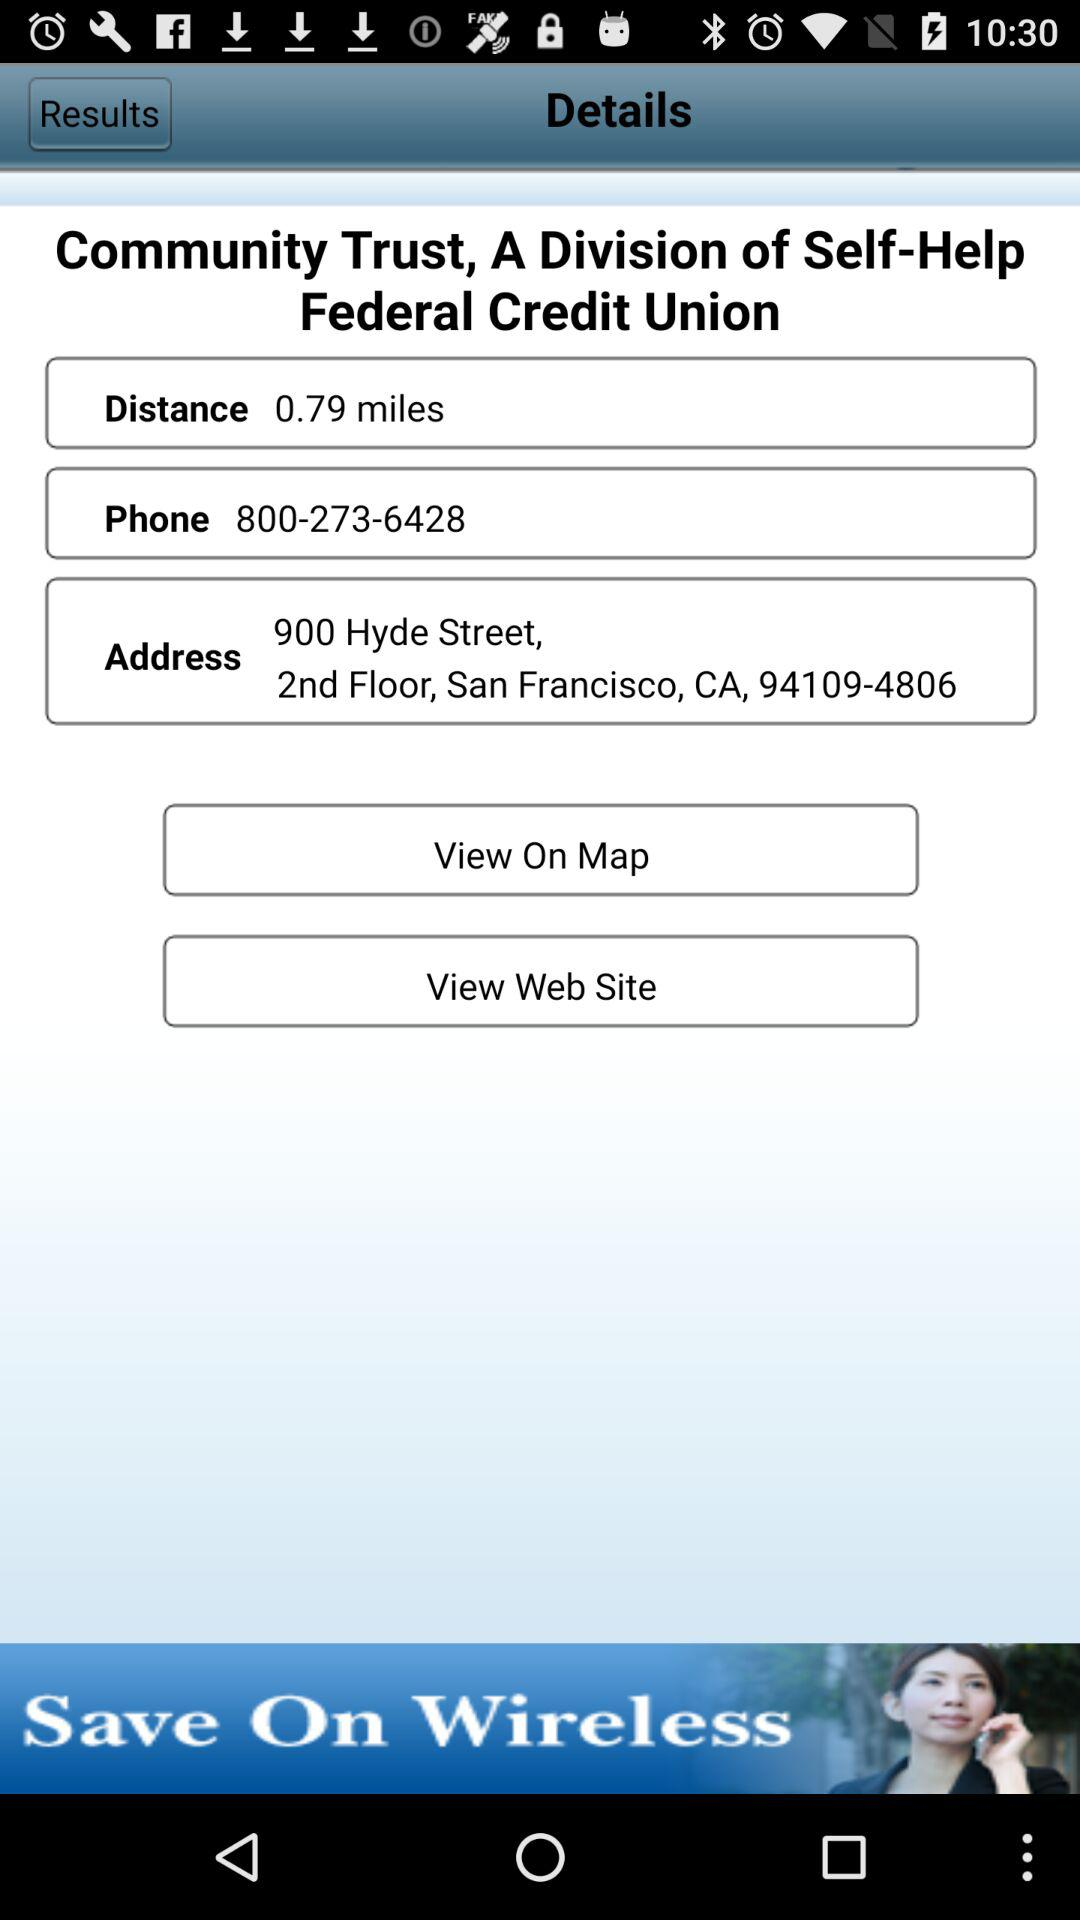How many phone numbers are displayed on this screen?
Answer the question using a single word or phrase. 1 